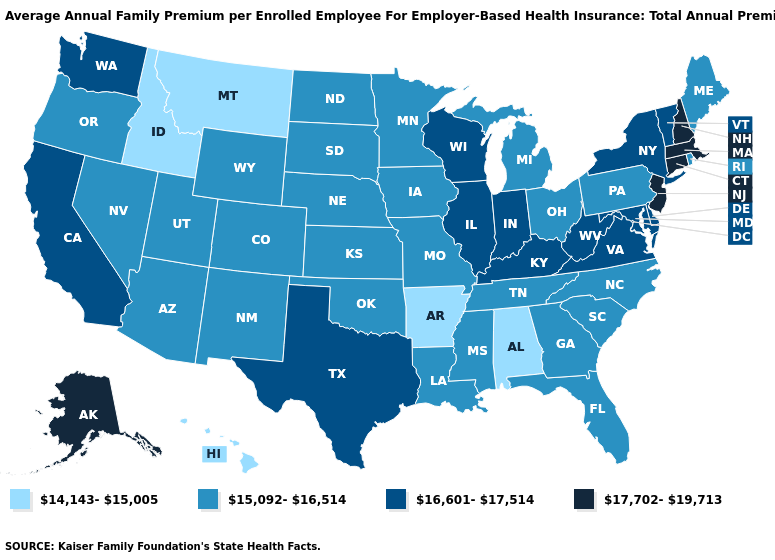What is the value of Mississippi?
Be succinct. 15,092-16,514. What is the value of Texas?
Be succinct. 16,601-17,514. Name the states that have a value in the range 15,092-16,514?
Short answer required. Arizona, Colorado, Florida, Georgia, Iowa, Kansas, Louisiana, Maine, Michigan, Minnesota, Mississippi, Missouri, Nebraska, Nevada, New Mexico, North Carolina, North Dakota, Ohio, Oklahoma, Oregon, Pennsylvania, Rhode Island, South Carolina, South Dakota, Tennessee, Utah, Wyoming. What is the value of Alaska?
Give a very brief answer. 17,702-19,713. Name the states that have a value in the range 16,601-17,514?
Give a very brief answer. California, Delaware, Illinois, Indiana, Kentucky, Maryland, New York, Texas, Vermont, Virginia, Washington, West Virginia, Wisconsin. Does Connecticut have the highest value in the USA?
Write a very short answer. Yes. Does Michigan have the same value as Minnesota?
Concise answer only. Yes. Does the map have missing data?
Keep it brief. No. Does Ohio have the highest value in the MidWest?
Give a very brief answer. No. Does Arkansas have the lowest value in the USA?
Be succinct. Yes. Which states have the lowest value in the South?
Be succinct. Alabama, Arkansas. Name the states that have a value in the range 14,143-15,005?
Concise answer only. Alabama, Arkansas, Hawaii, Idaho, Montana. Does New York have the same value as Wyoming?
Quick response, please. No. Name the states that have a value in the range 17,702-19,713?
Be succinct. Alaska, Connecticut, Massachusetts, New Hampshire, New Jersey. Which states have the lowest value in the USA?
Write a very short answer. Alabama, Arkansas, Hawaii, Idaho, Montana. 